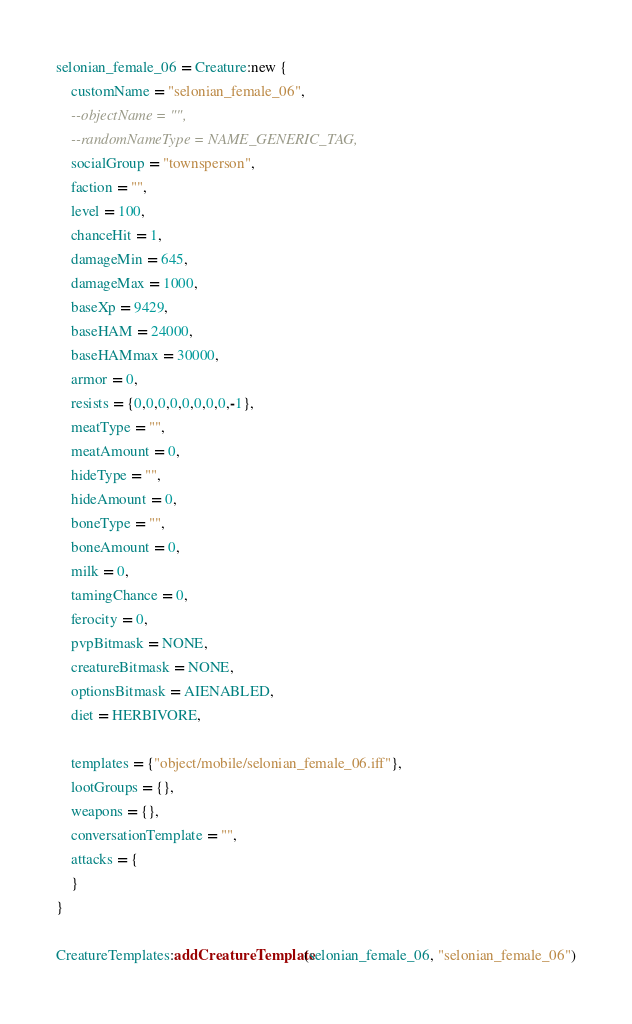Convert code to text. <code><loc_0><loc_0><loc_500><loc_500><_Lua_>selonian_female_06 = Creature:new {
	customName = "selonian_female_06",
	--objectName = "",
	--randomNameType = NAME_GENERIC_TAG,
	socialGroup = "townsperson",
	faction = "",
	level = 100,
	chanceHit = 1,
	damageMin = 645,
	damageMax = 1000,
	baseXp = 9429,
	baseHAM = 24000,
	baseHAMmax = 30000,
	armor = 0,
	resists = {0,0,0,0,0,0,0,0,-1},
	meatType = "",
	meatAmount = 0,
	hideType = "",
	hideAmount = 0,
	boneType = "",
	boneAmount = 0,
	milk = 0,
	tamingChance = 0,
	ferocity = 0,
	pvpBitmask = NONE,
	creatureBitmask = NONE,
	optionsBitmask = AIENABLED,
	diet = HERBIVORE,

	templates = {"object/mobile/selonian_female_06.iff"},
	lootGroups = {},
	weapons = {},
	conversationTemplate = "",
	attacks = {
	}
}

CreatureTemplates:addCreatureTemplate(selonian_female_06, "selonian_female_06")

</code> 